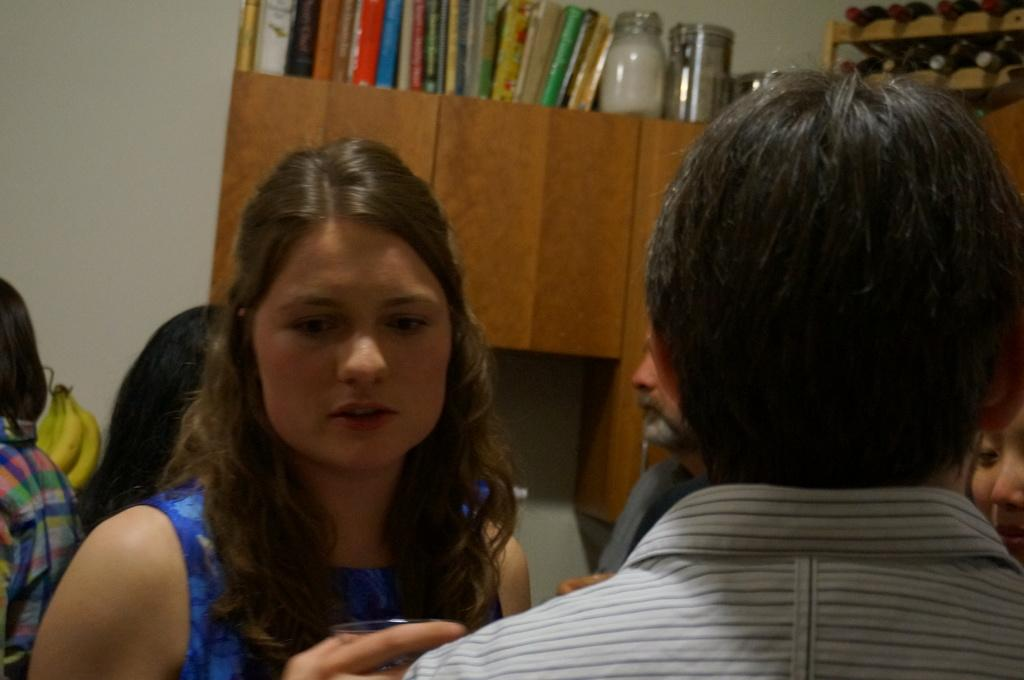<image>
Offer a succinct explanation of the picture presented. Books of unknown titles sits atop a cabinet shelf. 